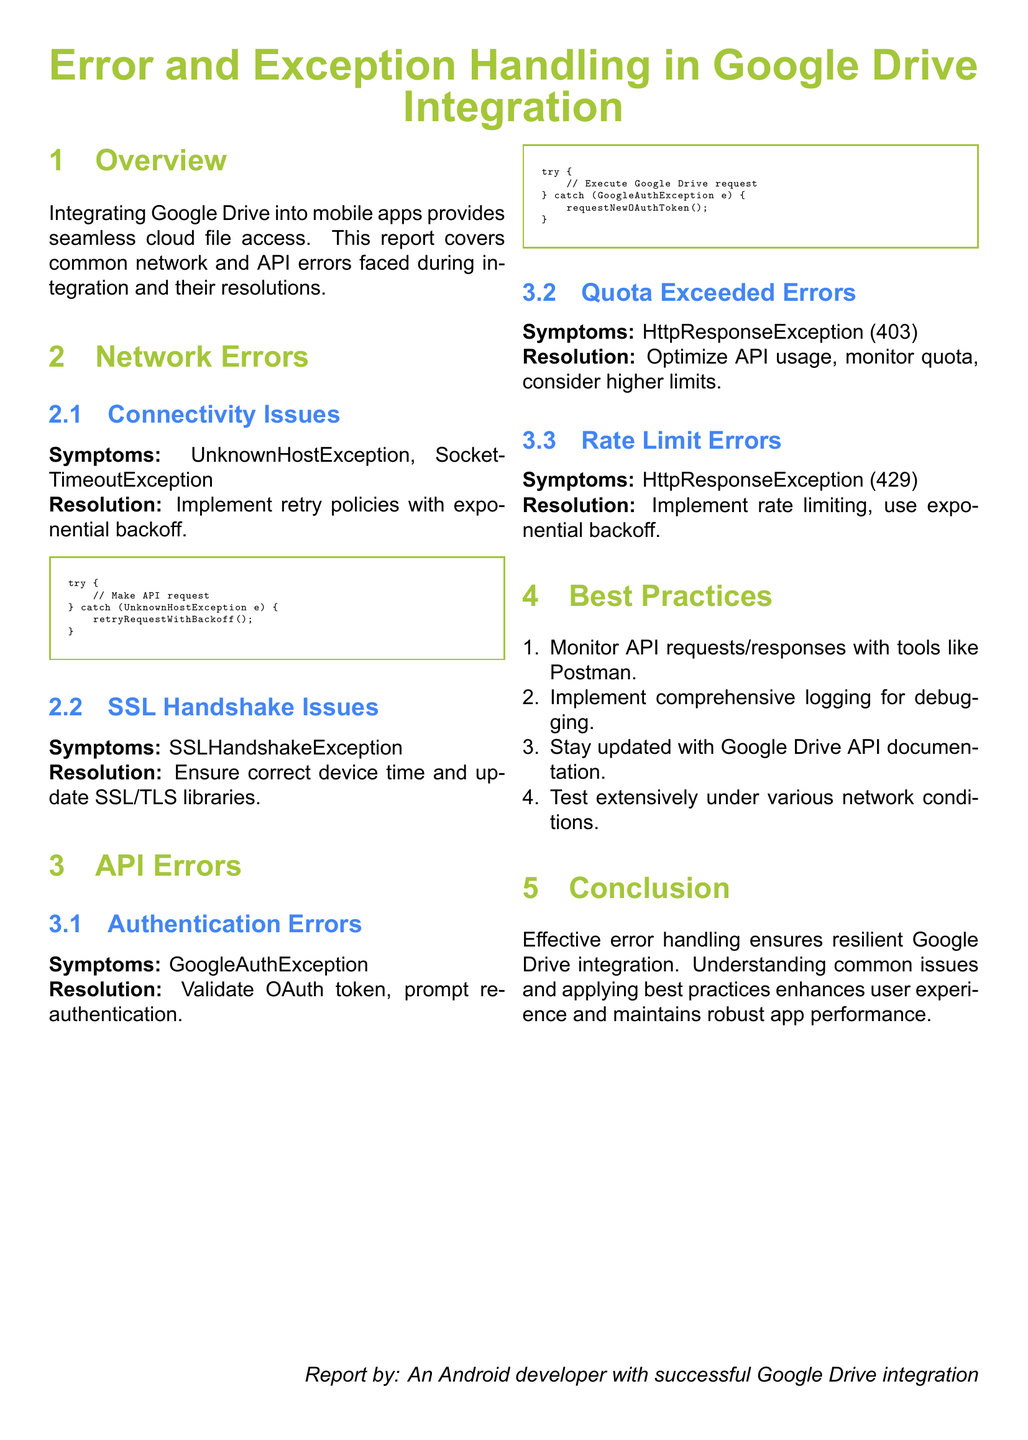What are the symptoms of connectivity issues? Symptoms of connectivity issues are specified as UnknownHostException and SocketTimeoutException.
Answer: UnknownHostException, SocketTimeoutException What is the resolution for SSL handshake issues? The resolution states to ensure correct device time and update SSL/TLS libraries.
Answer: Ensure correct device time and update SSL/TLS libraries What error signifies authentication issues? The document states GoogleAuthException as the symptom of authentication errors.
Answer: GoogleAuthException What should be done if the quota is exceeded? The document advises to optimize API usage, monitor quota, and consider higher limits.
Answer: Optimize API usage, monitor quota, consider higher limits What coding practice is suggested for handling authentication errors? The coding practice suggests requesting a new OAuth token when a GoogleAuthException occurs.
Answer: Request new OAuth token What is recommended for monitoring API requests? The best practice includes using tools like Postman for monitoring API requests/responses.
Answer: Tools like Postman What type of error does HttpResponseException (429) represent? HttpResponseException (429) represents rate limit errors according to the document.
Answer: Rate limit errors How can one enhance user experience in Google Drive integration? By understanding common issues and applying best practices one can enhance the user experience.
Answer: Understanding common issues, applying best practices What is the purpose of implementing retry policies? The purpose is to handle connectivity issues effectively during API requests.
Answer: Handle connectivity issues effectively 